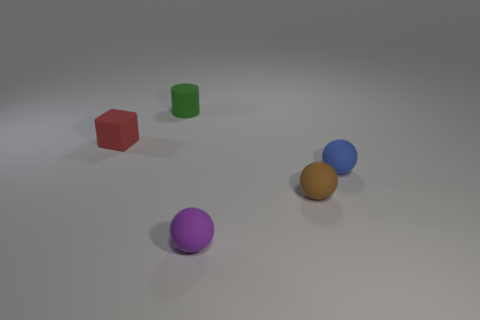Subtract all tiny purple rubber spheres. How many spheres are left? 2 Add 4 tiny green things. How many objects exist? 9 Subtract all brown spheres. How many spheres are left? 2 Subtract all big brown metal things. Subtract all blue rubber things. How many objects are left? 4 Add 4 small brown balls. How many small brown balls are left? 5 Add 1 red matte objects. How many red matte objects exist? 2 Subtract 0 blue cylinders. How many objects are left? 5 Subtract all blocks. How many objects are left? 4 Subtract 1 cylinders. How many cylinders are left? 0 Subtract all cyan cubes. Subtract all red balls. How many cubes are left? 1 